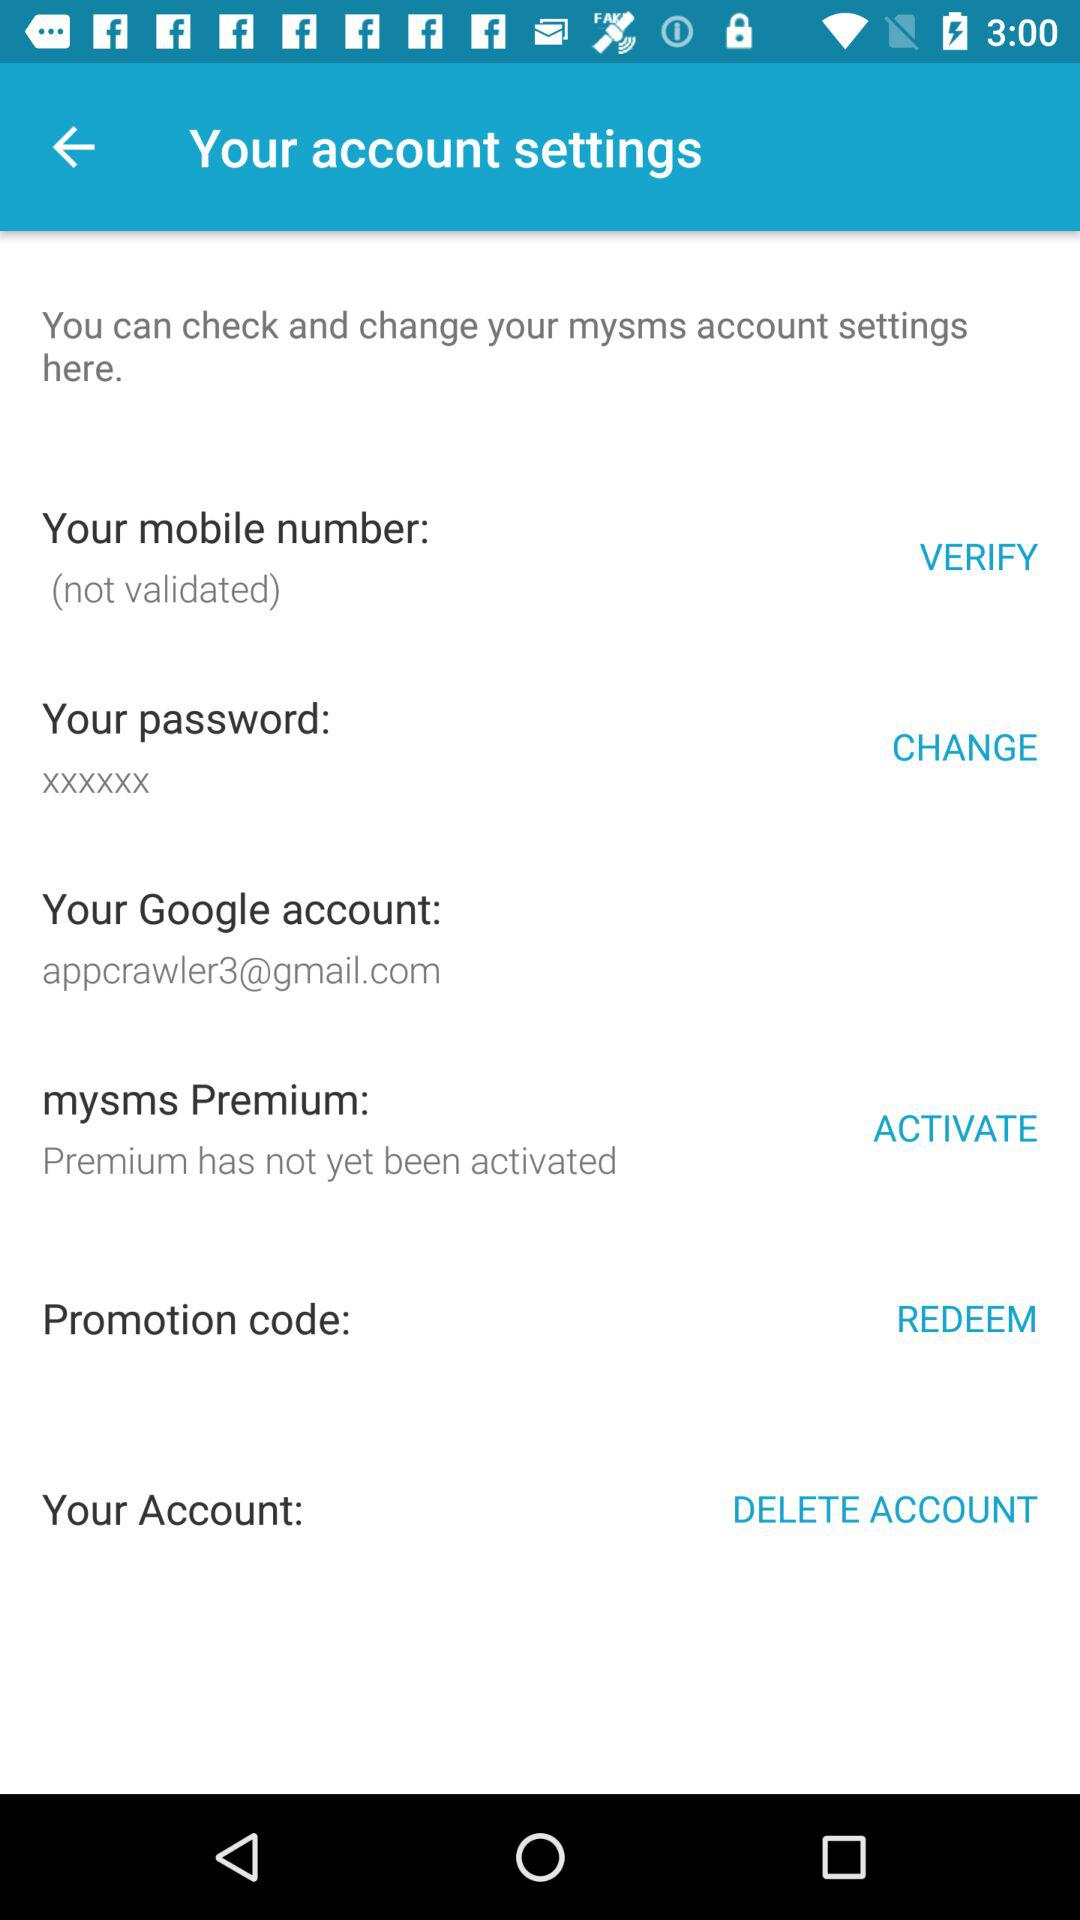Is the phone number validated? The phone number is not validated. 